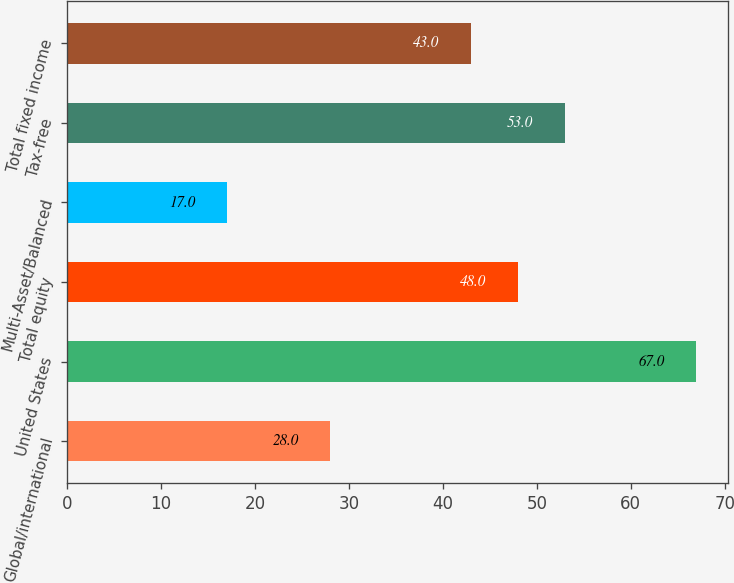Convert chart to OTSL. <chart><loc_0><loc_0><loc_500><loc_500><bar_chart><fcel>Global/international<fcel>United States<fcel>Total equity<fcel>Multi-Asset/Balanced<fcel>Tax-free<fcel>Total fixed income<nl><fcel>28<fcel>67<fcel>48<fcel>17<fcel>53<fcel>43<nl></chart> 